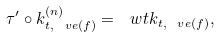Convert formula to latex. <formula><loc_0><loc_0><loc_500><loc_500>\tau ^ { \prime } \circ k _ { t , \ v e ( f ) } ^ { ( n ) } = \ w t { k } _ { t , \ v e ( f ) } ,</formula> 